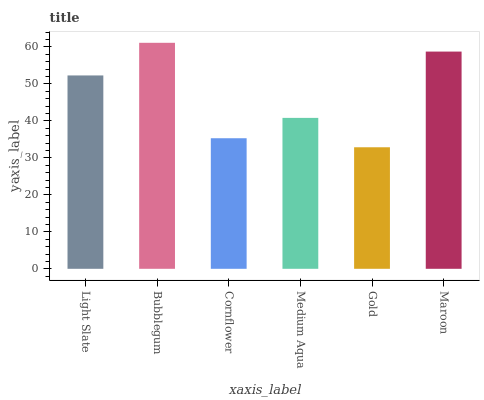Is Gold the minimum?
Answer yes or no. Yes. Is Bubblegum the maximum?
Answer yes or no. Yes. Is Cornflower the minimum?
Answer yes or no. No. Is Cornflower the maximum?
Answer yes or no. No. Is Bubblegum greater than Cornflower?
Answer yes or no. Yes. Is Cornflower less than Bubblegum?
Answer yes or no. Yes. Is Cornflower greater than Bubblegum?
Answer yes or no. No. Is Bubblegum less than Cornflower?
Answer yes or no. No. Is Light Slate the high median?
Answer yes or no. Yes. Is Medium Aqua the low median?
Answer yes or no. Yes. Is Bubblegum the high median?
Answer yes or no. No. Is Gold the low median?
Answer yes or no. No. 